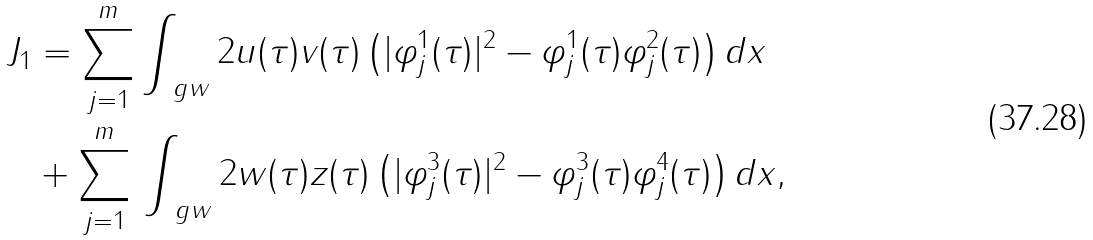<formula> <loc_0><loc_0><loc_500><loc_500>J _ { 1 } & = \sum _ { j = 1 } ^ { m } \int _ { \ g w } 2 u ( \tau ) v ( \tau ) \left ( | \varphi _ { j } ^ { 1 } ( \tau ) | ^ { 2 } - \varphi _ { j } ^ { 1 } ( \tau ) \varphi _ { j } ^ { 2 } ( \tau ) \right ) d x \\ & + \sum _ { j = 1 } ^ { m } \, \int _ { \ g w } 2 w ( \tau ) z ( \tau ) \left ( | \varphi _ { j } ^ { 3 } ( \tau ) | ^ { 2 } - \varphi _ { j } ^ { 3 } ( \tau ) \varphi _ { j } ^ { 4 } ( \tau ) \right ) d x ,</formula> 